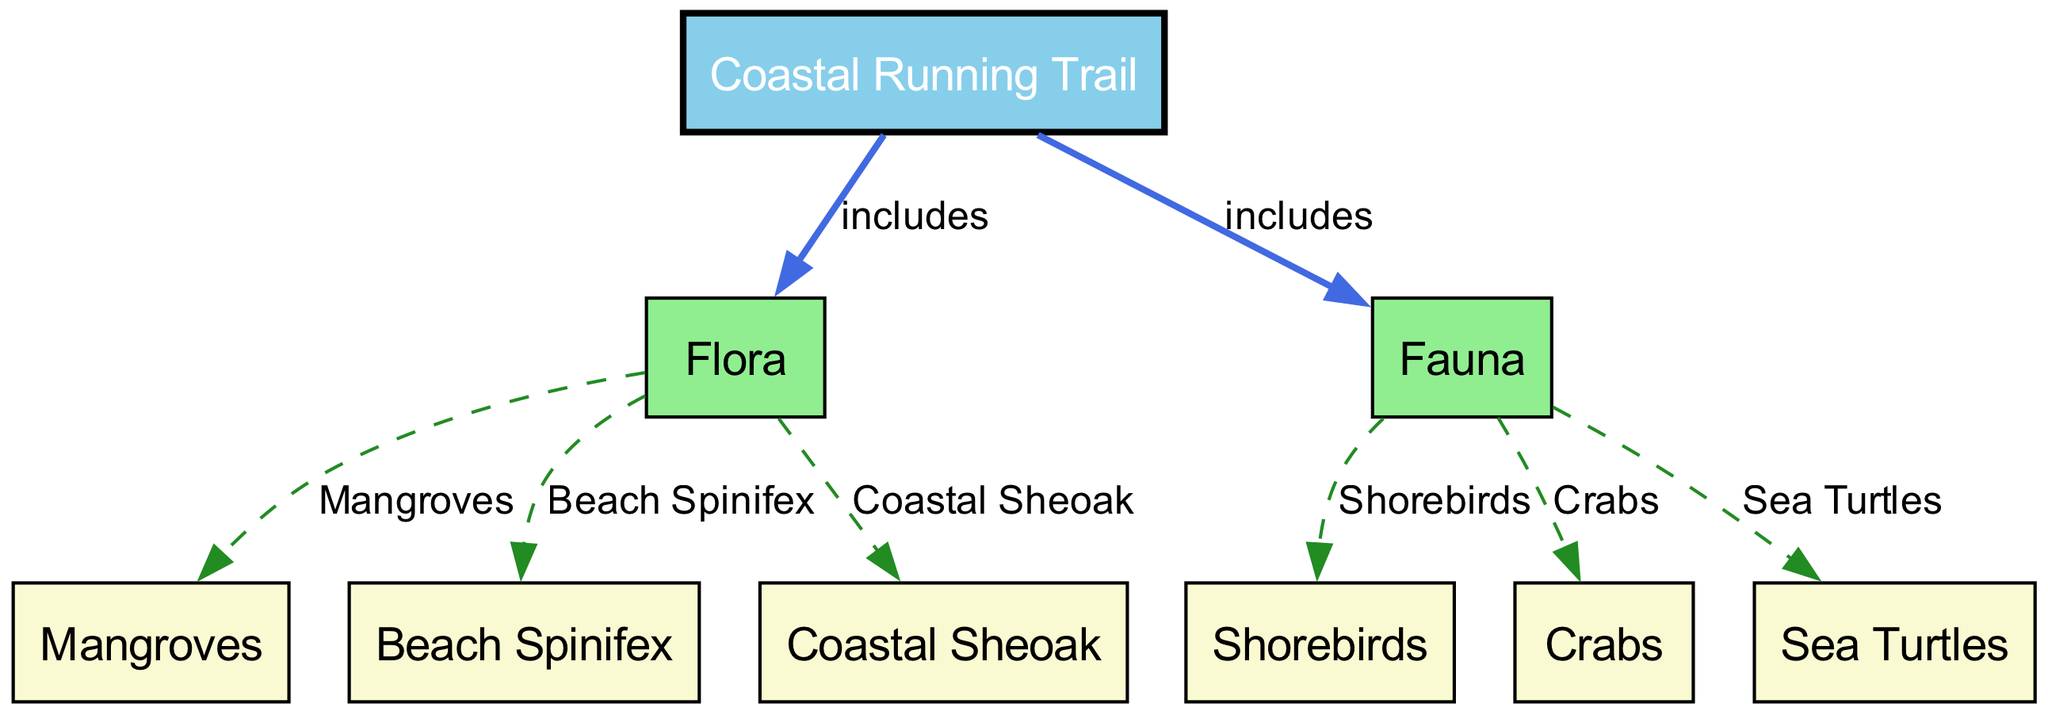What main categories of biodiversity are included in the coastal running trail? The diagram indicates two main categories of biodiversity related to the coastal running trail: Flora and Fauna. Each of these categories represents different living organisms found in the environment.
Answer: Flora and Fauna How many flora types are represented in the diagram? The diagram lists three specific types of flora: Mangroves, Beach Spinifex, and Coastal Sheoak. This adds up to a total of three different flora types connected to the coastal running trail.
Answer: Three Which specific fauna type is indicated to include shorebirds? Among the types of fauna, shorebirds are listed directly under the Fauna category, showing that they are specific fauna found within the coastal running trail ecosystem.
Answer: Shorebirds What relationship does the coastal running trail have with flora? The coastal running trail is connected to the Flora category with an “includes” relationship, indicating that various types of flora are part of the broader coastal running trail ecosystem.
Answer: includes How many types of fauna are illustrated in the diagram? There are three types of fauna represented in the diagram: Shorebirds, Crabs, and Sea Turtles, showcasing the diversity of animal life associated with the coastal trail.
Answer: Three What type of vegetation is represented by beach spinifex? According to the diagram, Beach Spinifex is categorized as a type of Flora, specifically indicating its role in the coastal ecosystem of the running trail.
Answer: Flora Which fauna type is most likely found in sandy coastal areas? The diagram indicates that Crabs are associated with the Fauna category, and they are likely to be found in sandy coastal areas among the types of fauna illustrated.
Answer: Crabs What role do mangroves play in this diagram? Mangroves are categorized under Flora, indicating their essential role in the coastal ecosystem by providing habitats and contributing to biodiversity in running trails.
Answer: Flora How does the diagram categorize the relationship between coastal sheoak and flora? Coastal Sheoak is specifically indicated to be a part of the Flora category in the diagram, which means it forms a part of the vegetation along the coastal running trail.
Answer: Flora 